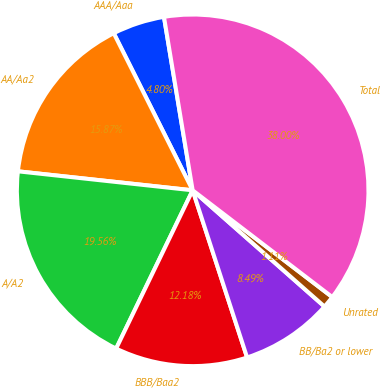<chart> <loc_0><loc_0><loc_500><loc_500><pie_chart><fcel>AAA/Aaa<fcel>AA/Aa2<fcel>A/A2<fcel>BBB/Baa2<fcel>BB/Ba2 or lower<fcel>Unrated<fcel>Total<nl><fcel>4.8%<fcel>15.87%<fcel>19.56%<fcel>12.18%<fcel>8.49%<fcel>1.11%<fcel>38.01%<nl></chart> 